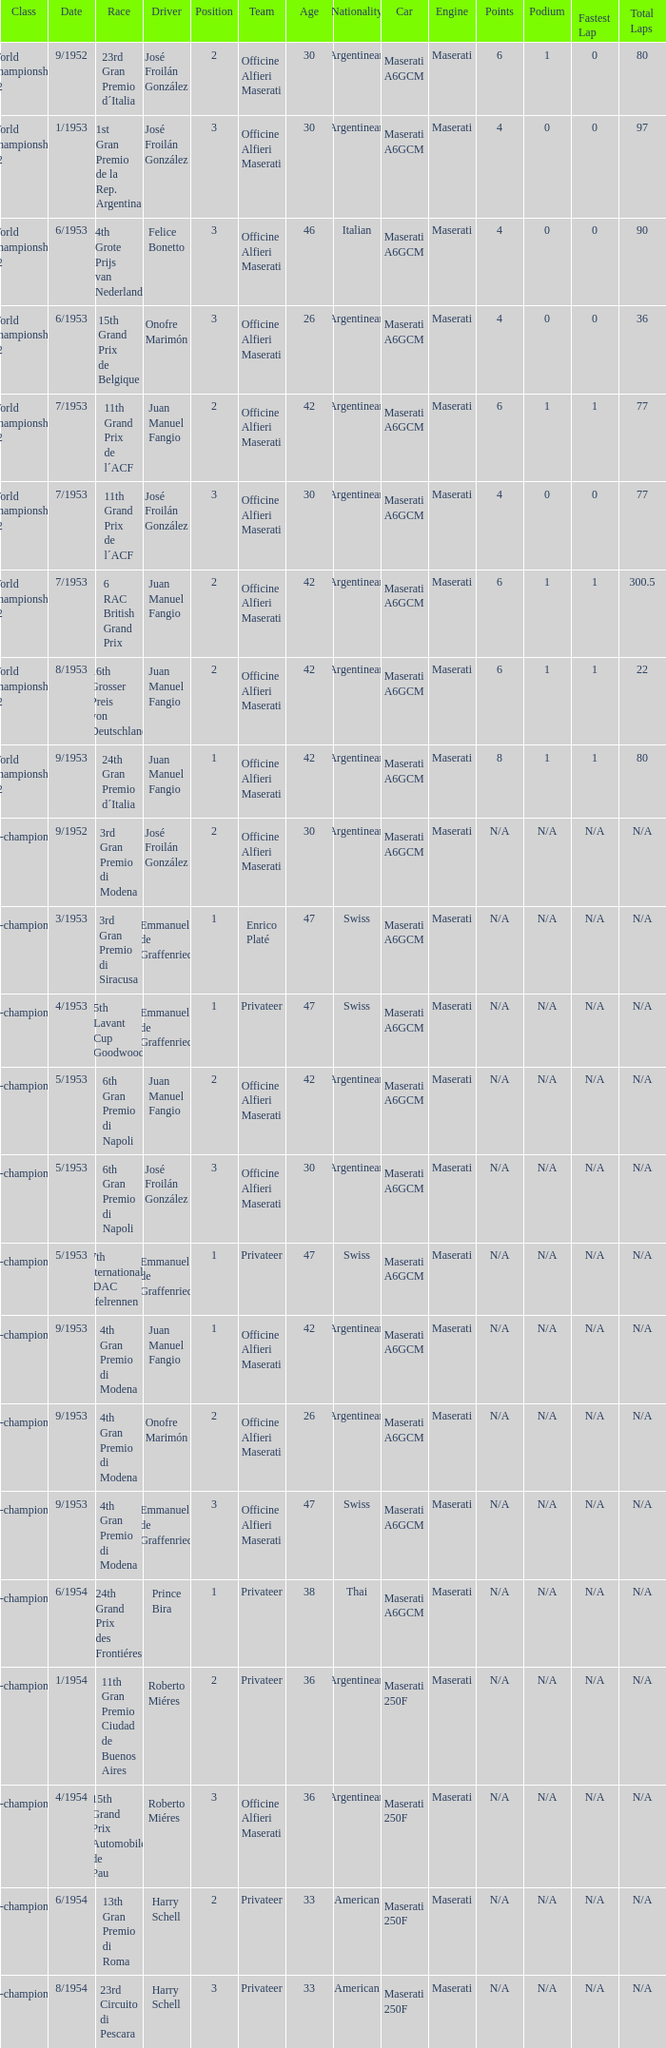What team has a drive name emmanuel de graffenried and a position larger than 1 as well as the date of 9/1953? Officine Alfieri Maserati. 